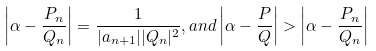<formula> <loc_0><loc_0><loc_500><loc_500>\left | \alpha - \frac { P _ { n } } { Q _ { n } } \right | = \frac { 1 } { | a _ { n + 1 } | | Q _ { n } | ^ { 2 } } , a n d \left | \alpha - \frac { P } { Q } \right | > \left | \alpha - \frac { P _ { n } } { Q _ { n } } \right |</formula> 